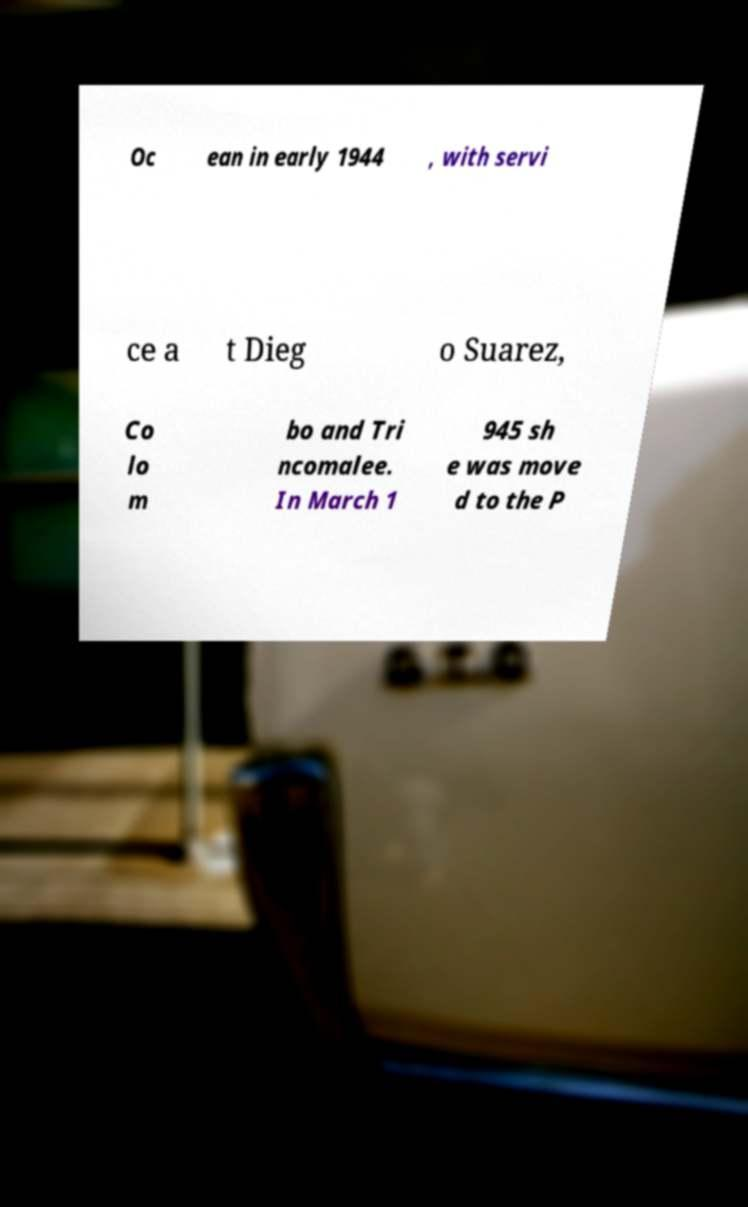There's text embedded in this image that I need extracted. Can you transcribe it verbatim? Oc ean in early 1944 , with servi ce a t Dieg o Suarez, Co lo m bo and Tri ncomalee. In March 1 945 sh e was move d to the P 